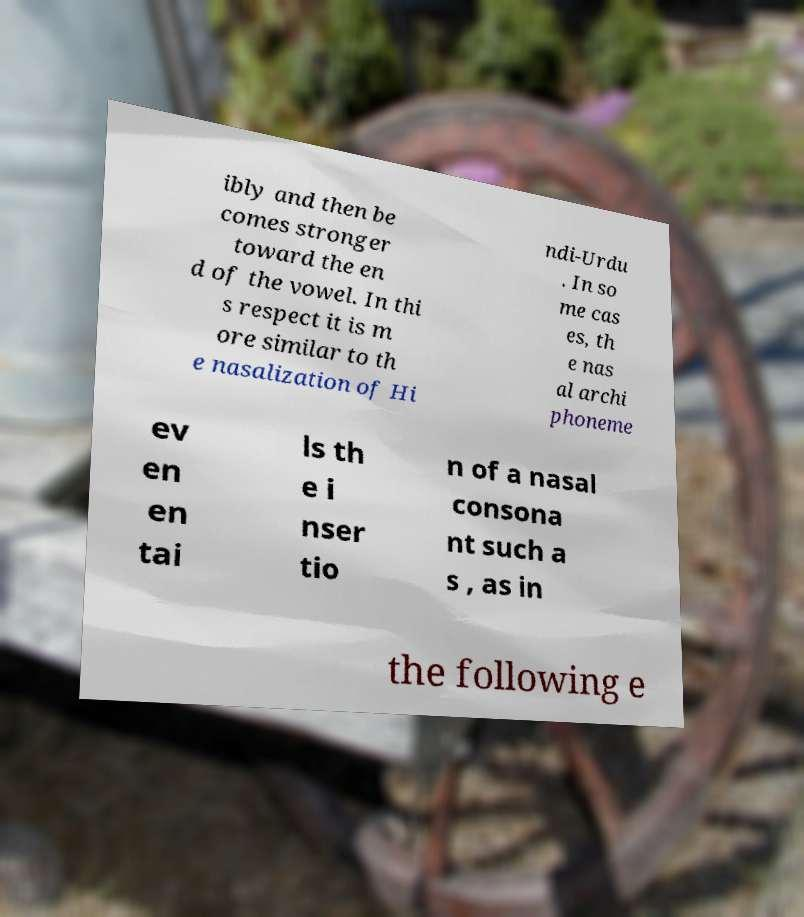For documentation purposes, I need the text within this image transcribed. Could you provide that? ibly and then be comes stronger toward the en d of the vowel. In thi s respect it is m ore similar to th e nasalization of Hi ndi-Urdu . In so me cas es, th e nas al archi phoneme ev en en tai ls th e i nser tio n of a nasal consona nt such a s , as in the following e 